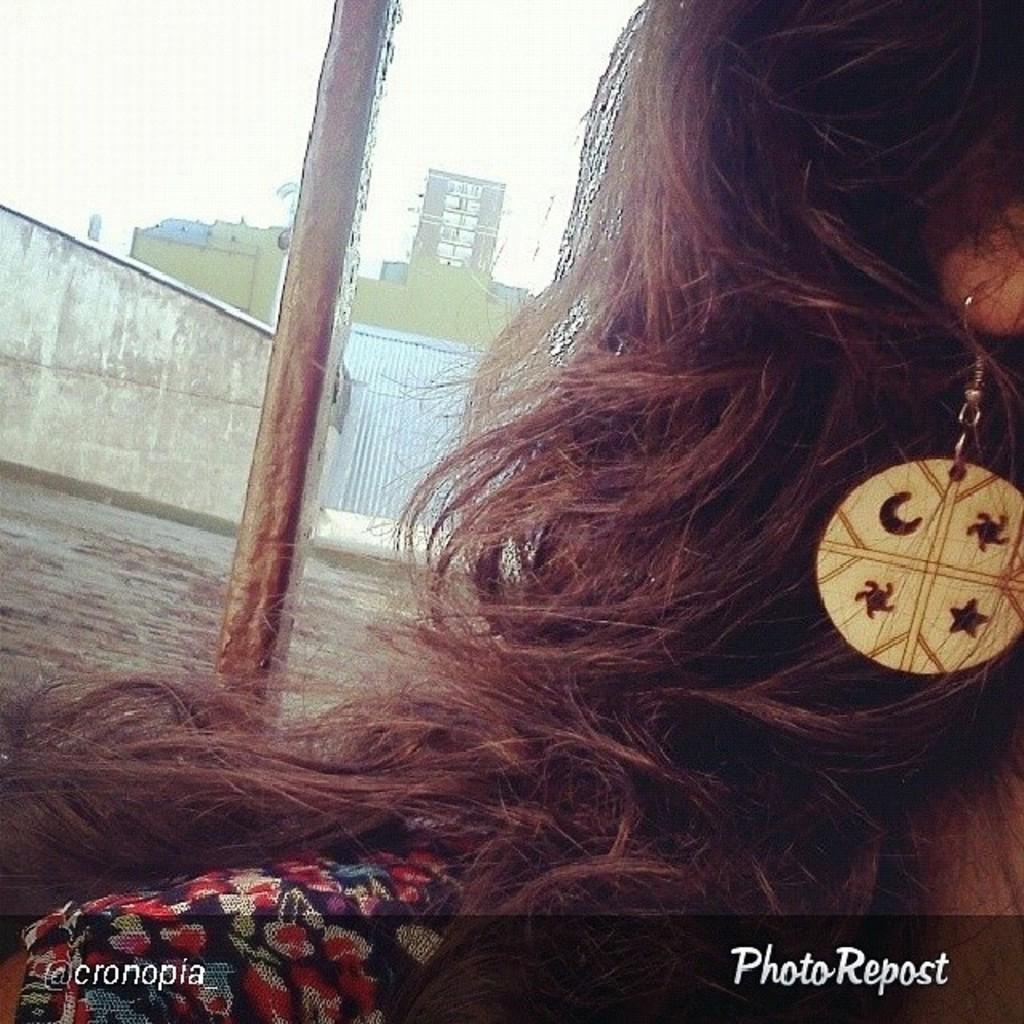Who is present in the image? There is a woman in the image. What is the woman wearing in the image? The woman is wearing earrings in the image. What can be seen in the background of the image? There is a pole, buildings, and the sky visible in the background of the image. What is written or displayed at the bottom of the image? There is text at the bottom of the image. What type of rifle is the woman holding in the image? There is no rifle present in the image; the woman is not holding any weapon. 